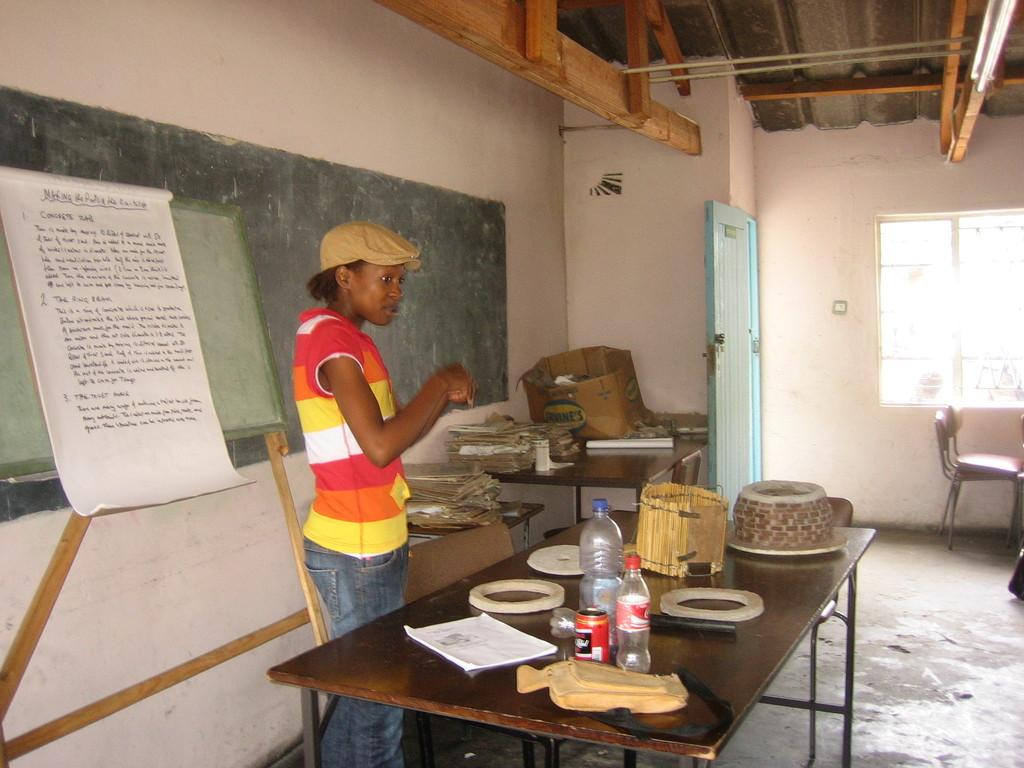What piece of furniture is present in the image? There is a table in the image. What object can be seen on the table? There is a book and bottles on the table. Where is the person located in the image? The person is standing at the left side of the image. What is behind the person in the image? There is a board behind the person. What architectural feature is present at the right side of the image? There is a window at the right side of the image. What piece of furniture is located near the window? There is a chair at the right side of the image. Can you tell me how many chickens are visible in the image? There are no chickens present in the image. What type of elbow is being used by the person in the image? The person in the image does not appear to be using an elbow, as they are standing. 